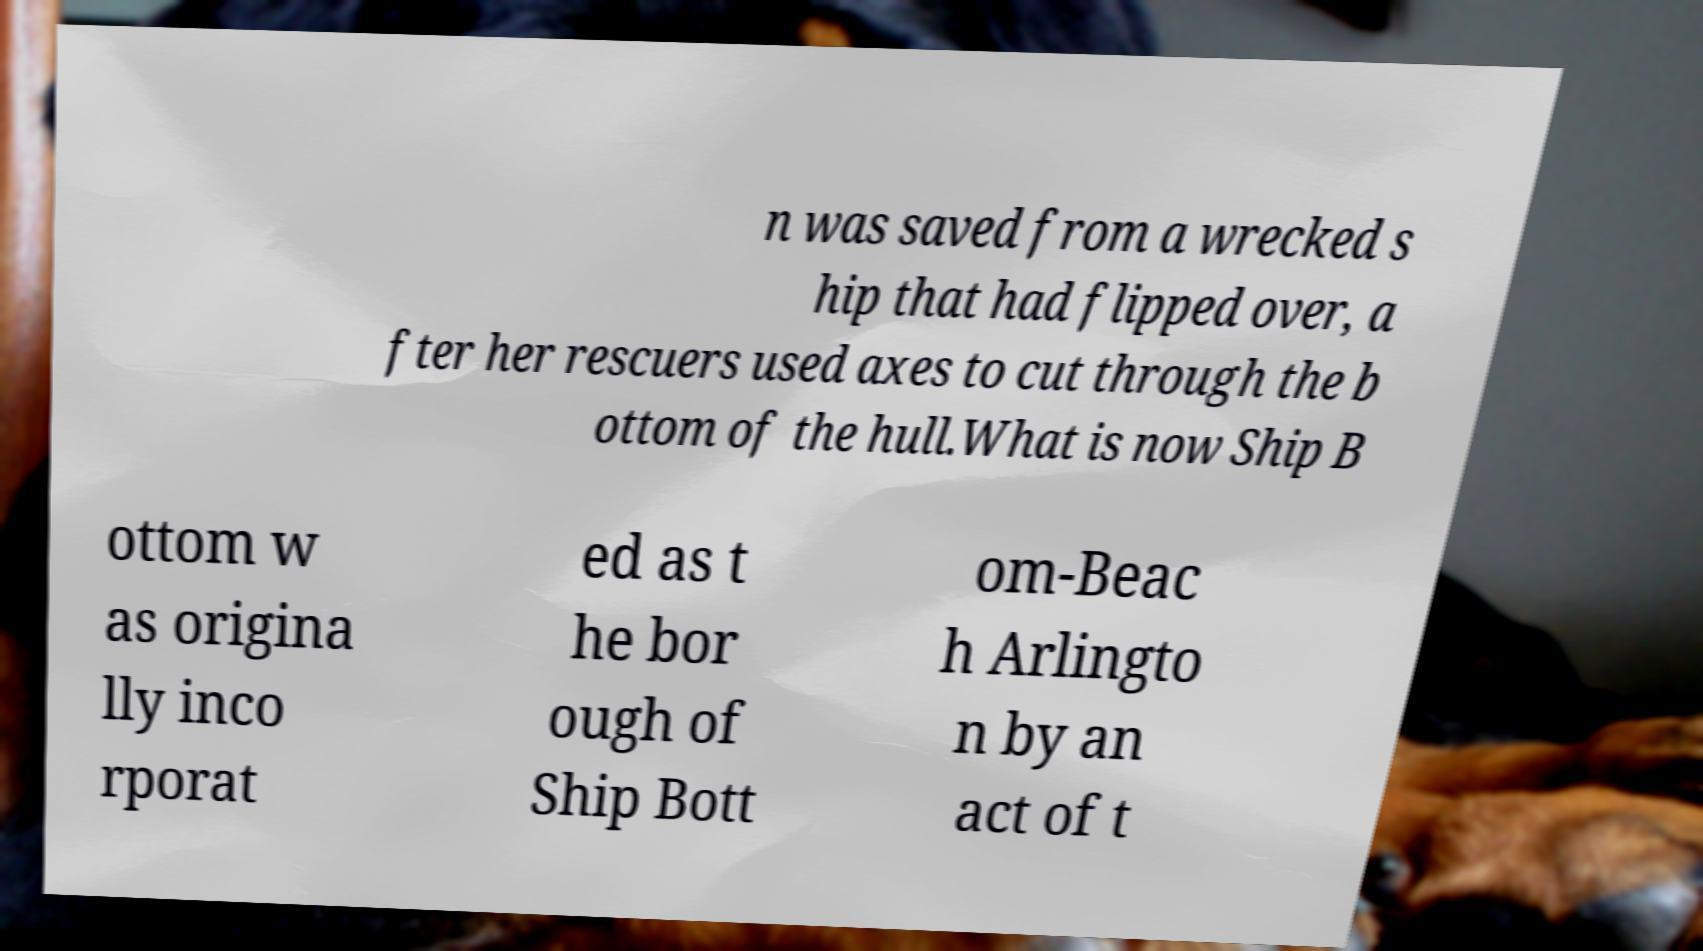Can you accurately transcribe the text from the provided image for me? n was saved from a wrecked s hip that had flipped over, a fter her rescuers used axes to cut through the b ottom of the hull.What is now Ship B ottom w as origina lly inco rporat ed as t he bor ough of Ship Bott om-Beac h Arlingto n by an act of t 